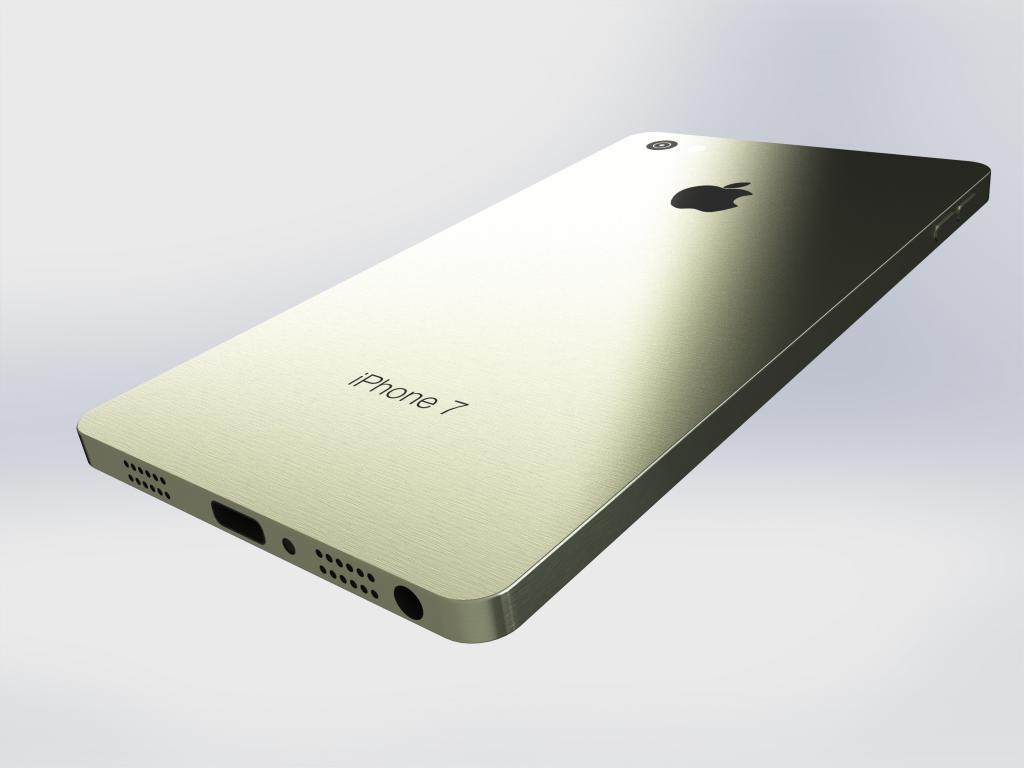Provide a one-sentence caption for the provided image. A iPhone7 floating with a blurred background reflecting light. 